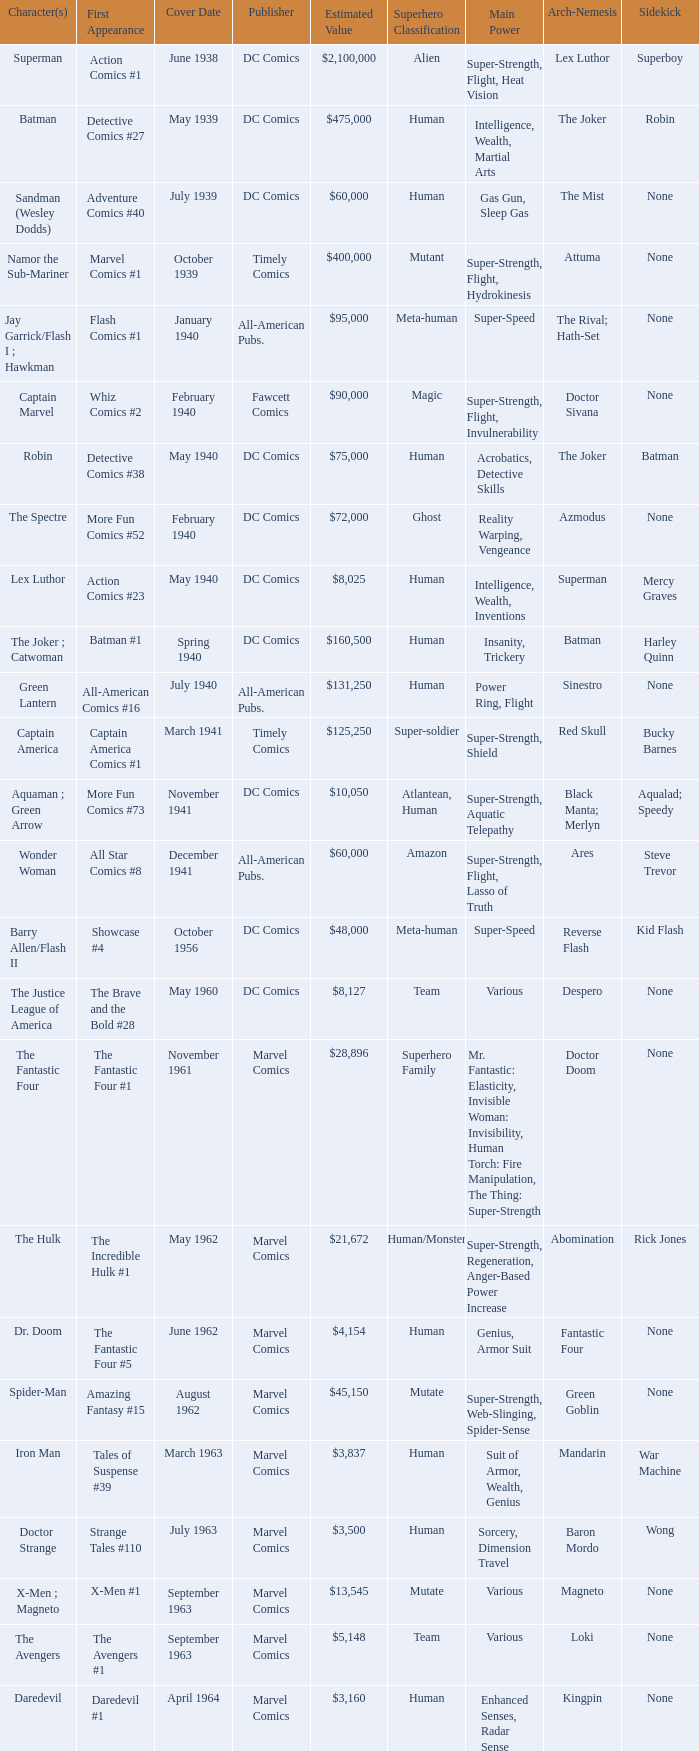Who issues wolverine? Marvel Comics. 